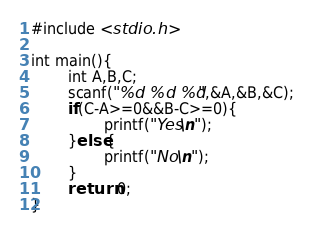Convert code to text. <code><loc_0><loc_0><loc_500><loc_500><_C++_>#include <stdio.h>

int main(){
        int A,B,C;
        scanf("%d %d %d",&A,&B,&C);
        if(C-A>=0&&B-C>=0){
                printf("Yes\n");
        }else{
                printf("No\n");
        }
        return 0;
}
</code> 